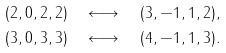<formula> <loc_0><loc_0><loc_500><loc_500>( 2 , 0 , 2 , 2 ) & \quad \longleftrightarrow \quad ( 3 , - 1 , 1 , 2 ) , \\ ( 3 , 0 , 3 , 3 ) & \quad \longleftrightarrow \quad ( 4 , - 1 , 1 , 3 ) .</formula> 